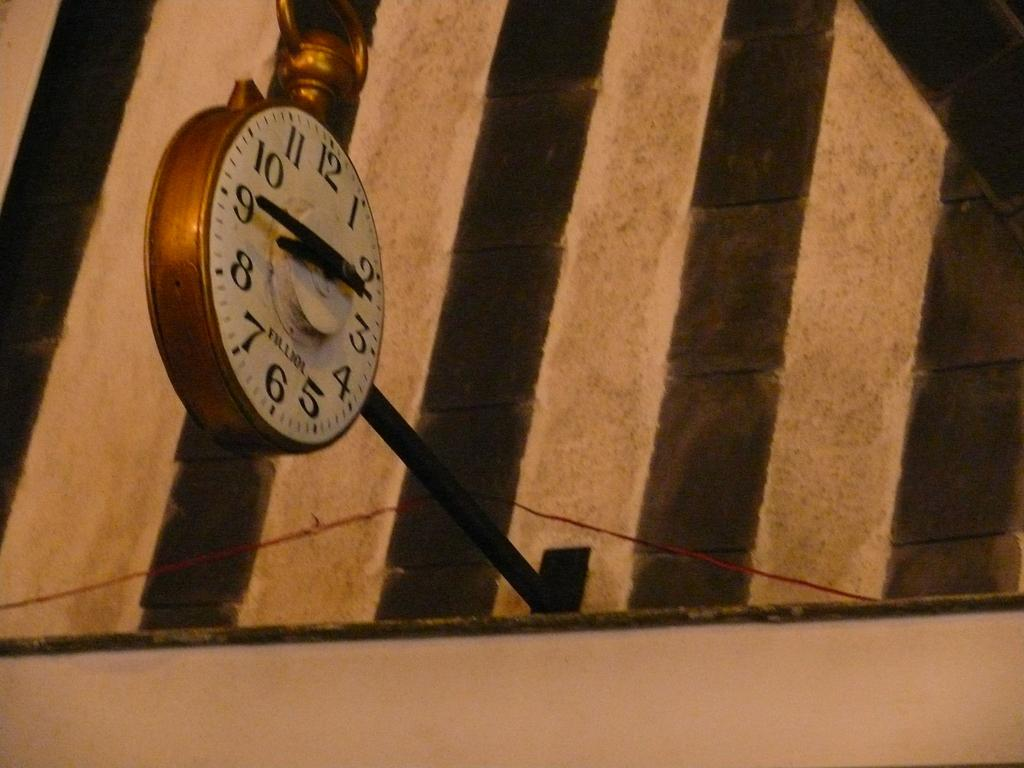<image>
Create a compact narrative representing the image presented. The large clock is a replica of a pocket watch and the time reads 8:45. 